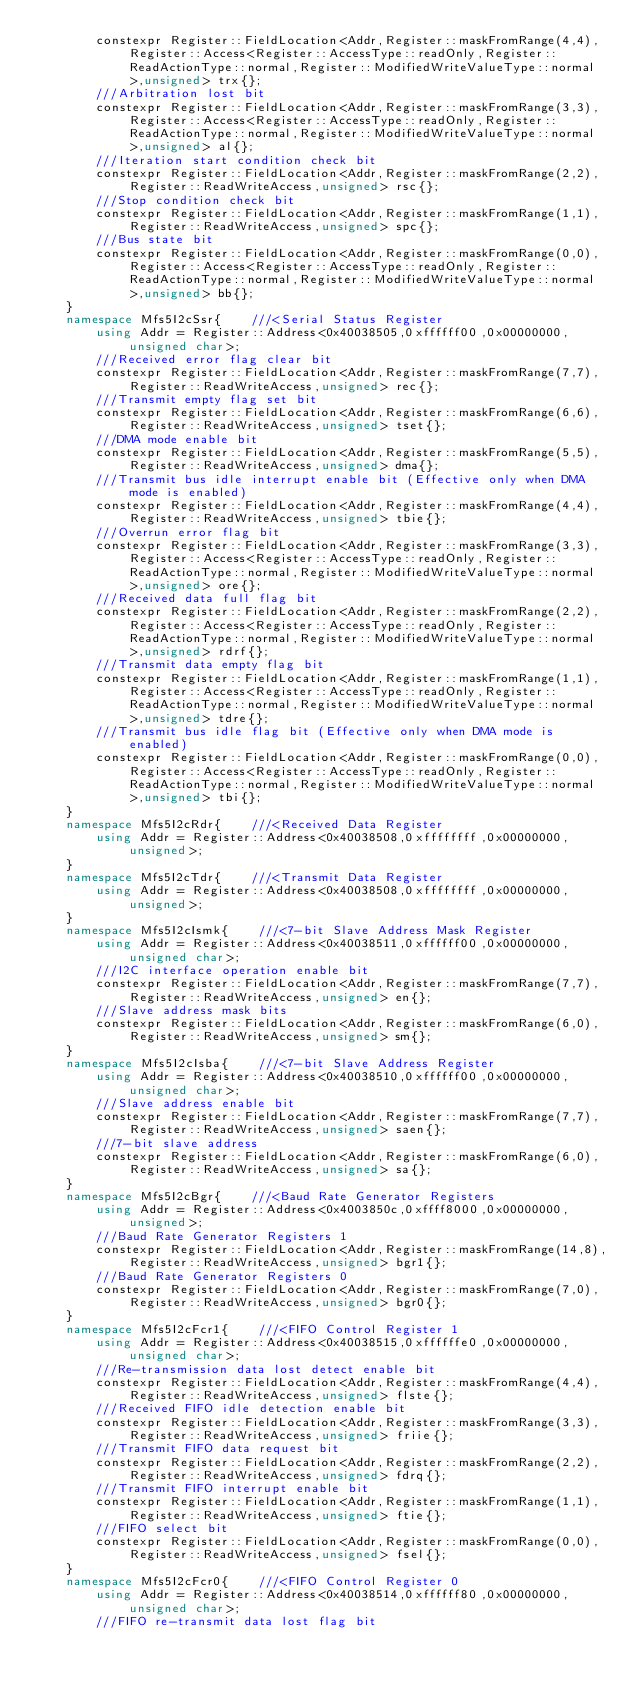<code> <loc_0><loc_0><loc_500><loc_500><_C++_>        constexpr Register::FieldLocation<Addr,Register::maskFromRange(4,4),Register::Access<Register::AccessType::readOnly,Register::ReadActionType::normal,Register::ModifiedWriteValueType::normal>,unsigned> trx{}; 
        ///Arbitration lost bit
        constexpr Register::FieldLocation<Addr,Register::maskFromRange(3,3),Register::Access<Register::AccessType::readOnly,Register::ReadActionType::normal,Register::ModifiedWriteValueType::normal>,unsigned> al{}; 
        ///Iteration start condition check bit 
        constexpr Register::FieldLocation<Addr,Register::maskFromRange(2,2),Register::ReadWriteAccess,unsigned> rsc{}; 
        ///Stop condition check bit 
        constexpr Register::FieldLocation<Addr,Register::maskFromRange(1,1),Register::ReadWriteAccess,unsigned> spc{}; 
        ///Bus state bit 
        constexpr Register::FieldLocation<Addr,Register::maskFromRange(0,0),Register::Access<Register::AccessType::readOnly,Register::ReadActionType::normal,Register::ModifiedWriteValueType::normal>,unsigned> bb{}; 
    }
    namespace Mfs5I2cSsr{    ///<Serial Status Register 
        using Addr = Register::Address<0x40038505,0xffffff00,0x00000000,unsigned char>;
        ///Received error flag clear bit
        constexpr Register::FieldLocation<Addr,Register::maskFromRange(7,7),Register::ReadWriteAccess,unsigned> rec{}; 
        ///Transmit empty flag set bit
        constexpr Register::FieldLocation<Addr,Register::maskFromRange(6,6),Register::ReadWriteAccess,unsigned> tset{}; 
        ///DMA mode enable bit 
        constexpr Register::FieldLocation<Addr,Register::maskFromRange(5,5),Register::ReadWriteAccess,unsigned> dma{}; 
        ///Transmit bus idle interrupt enable bit (Effective only when DMA mode is enabled) 
        constexpr Register::FieldLocation<Addr,Register::maskFromRange(4,4),Register::ReadWriteAccess,unsigned> tbie{}; 
        ///Overrun error flag bit
        constexpr Register::FieldLocation<Addr,Register::maskFromRange(3,3),Register::Access<Register::AccessType::readOnly,Register::ReadActionType::normal,Register::ModifiedWriteValueType::normal>,unsigned> ore{}; 
        ///Received data full flag bit 
        constexpr Register::FieldLocation<Addr,Register::maskFromRange(2,2),Register::Access<Register::AccessType::readOnly,Register::ReadActionType::normal,Register::ModifiedWriteValueType::normal>,unsigned> rdrf{}; 
        ///Transmit data empty flag bit 
        constexpr Register::FieldLocation<Addr,Register::maskFromRange(1,1),Register::Access<Register::AccessType::readOnly,Register::ReadActionType::normal,Register::ModifiedWriteValueType::normal>,unsigned> tdre{}; 
        ///Transmit bus idle flag bit (Effective only when DMA mode is enabled) 
        constexpr Register::FieldLocation<Addr,Register::maskFromRange(0,0),Register::Access<Register::AccessType::readOnly,Register::ReadActionType::normal,Register::ModifiedWriteValueType::normal>,unsigned> tbi{}; 
    }
    namespace Mfs5I2cRdr{    ///<Received Data Register
        using Addr = Register::Address<0x40038508,0xffffffff,0x00000000,unsigned>;
    }
    namespace Mfs5I2cTdr{    ///<Transmit Data Register
        using Addr = Register::Address<0x40038508,0xffffffff,0x00000000,unsigned>;
    }
    namespace Mfs5I2cIsmk{    ///<7-bit Slave Address Mask Register
        using Addr = Register::Address<0x40038511,0xffffff00,0x00000000,unsigned char>;
        ///I2C interface operation enable bit
        constexpr Register::FieldLocation<Addr,Register::maskFromRange(7,7),Register::ReadWriteAccess,unsigned> en{}; 
        ///Slave address mask bits
        constexpr Register::FieldLocation<Addr,Register::maskFromRange(6,0),Register::ReadWriteAccess,unsigned> sm{}; 
    }
    namespace Mfs5I2cIsba{    ///<7-bit Slave Address Register
        using Addr = Register::Address<0x40038510,0xffffff00,0x00000000,unsigned char>;
        ///Slave address enable bit
        constexpr Register::FieldLocation<Addr,Register::maskFromRange(7,7),Register::ReadWriteAccess,unsigned> saen{}; 
        ///7-bit slave address
        constexpr Register::FieldLocation<Addr,Register::maskFromRange(6,0),Register::ReadWriteAccess,unsigned> sa{}; 
    }
    namespace Mfs5I2cBgr{    ///<Baud Rate Generator Registers
        using Addr = Register::Address<0x4003850c,0xffff8000,0x00000000,unsigned>;
        ///Baud Rate Generator Registers 1
        constexpr Register::FieldLocation<Addr,Register::maskFromRange(14,8),Register::ReadWriteAccess,unsigned> bgr1{}; 
        ///Baud Rate Generator Registers 0
        constexpr Register::FieldLocation<Addr,Register::maskFromRange(7,0),Register::ReadWriteAccess,unsigned> bgr0{}; 
    }
    namespace Mfs5I2cFcr1{    ///<FIFO Control Register 1
        using Addr = Register::Address<0x40038515,0xffffffe0,0x00000000,unsigned char>;
        ///Re-transmission data lost detect enable bit 
        constexpr Register::FieldLocation<Addr,Register::maskFromRange(4,4),Register::ReadWriteAccess,unsigned> flste{}; 
        ///Received FIFO idle detection enable bit 
        constexpr Register::FieldLocation<Addr,Register::maskFromRange(3,3),Register::ReadWriteAccess,unsigned> friie{}; 
        ///Transmit FIFO data request bit
        constexpr Register::FieldLocation<Addr,Register::maskFromRange(2,2),Register::ReadWriteAccess,unsigned> fdrq{}; 
        ///Transmit FIFO interrupt enable bit 
        constexpr Register::FieldLocation<Addr,Register::maskFromRange(1,1),Register::ReadWriteAccess,unsigned> ftie{}; 
        ///FIFO select bit 
        constexpr Register::FieldLocation<Addr,Register::maskFromRange(0,0),Register::ReadWriteAccess,unsigned> fsel{}; 
    }
    namespace Mfs5I2cFcr0{    ///<FIFO Control Register 0
        using Addr = Register::Address<0x40038514,0xffffff80,0x00000000,unsigned char>;
        ///FIFO re-transmit data lost flag bit </code> 